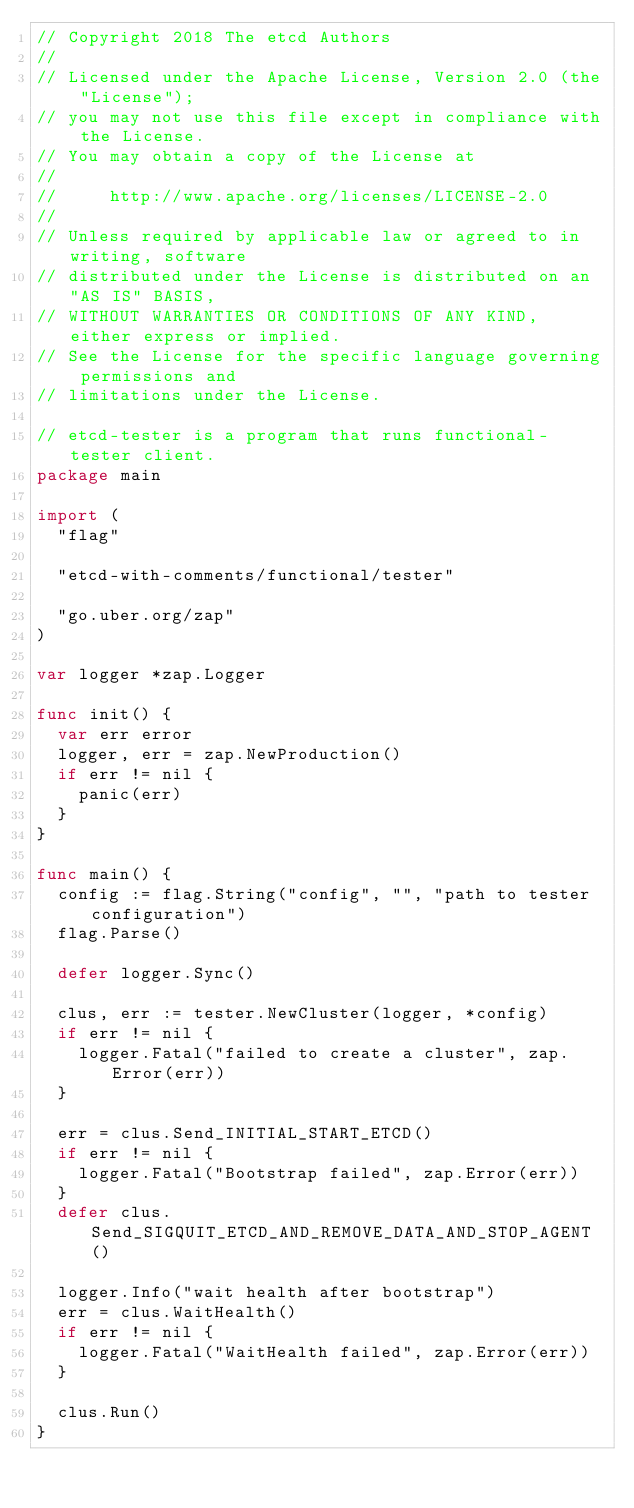Convert code to text. <code><loc_0><loc_0><loc_500><loc_500><_Go_>// Copyright 2018 The etcd Authors
//
// Licensed under the Apache License, Version 2.0 (the "License");
// you may not use this file except in compliance with the License.
// You may obtain a copy of the License at
//
//     http://www.apache.org/licenses/LICENSE-2.0
//
// Unless required by applicable law or agreed to in writing, software
// distributed under the License is distributed on an "AS IS" BASIS,
// WITHOUT WARRANTIES OR CONDITIONS OF ANY KIND, either express or implied.
// See the License for the specific language governing permissions and
// limitations under the License.

// etcd-tester is a program that runs functional-tester client.
package main

import (
	"flag"

	"etcd-with-comments/functional/tester"

	"go.uber.org/zap"
)

var logger *zap.Logger

func init() {
	var err error
	logger, err = zap.NewProduction()
	if err != nil {
		panic(err)
	}
}

func main() {
	config := flag.String("config", "", "path to tester configuration")
	flag.Parse()

	defer logger.Sync()

	clus, err := tester.NewCluster(logger, *config)
	if err != nil {
		logger.Fatal("failed to create a cluster", zap.Error(err))
	}

	err = clus.Send_INITIAL_START_ETCD()
	if err != nil {
		logger.Fatal("Bootstrap failed", zap.Error(err))
	}
	defer clus.Send_SIGQUIT_ETCD_AND_REMOVE_DATA_AND_STOP_AGENT()

	logger.Info("wait health after bootstrap")
	err = clus.WaitHealth()
	if err != nil {
		logger.Fatal("WaitHealth failed", zap.Error(err))
	}

	clus.Run()
}
</code> 